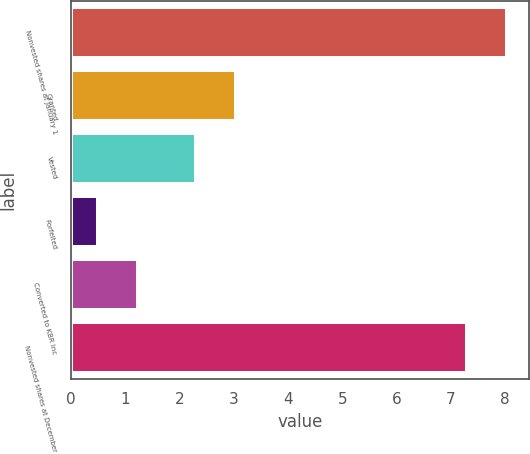Convert chart. <chart><loc_0><loc_0><loc_500><loc_500><bar_chart><fcel>Nonvested shares at January 1<fcel>Granted<fcel>Vested<fcel>Forfeited<fcel>Converted to KBR Inc<fcel>Nonvested shares at December<nl><fcel>8.04<fcel>3.04<fcel>2.3<fcel>0.5<fcel>1.24<fcel>7.3<nl></chart> 